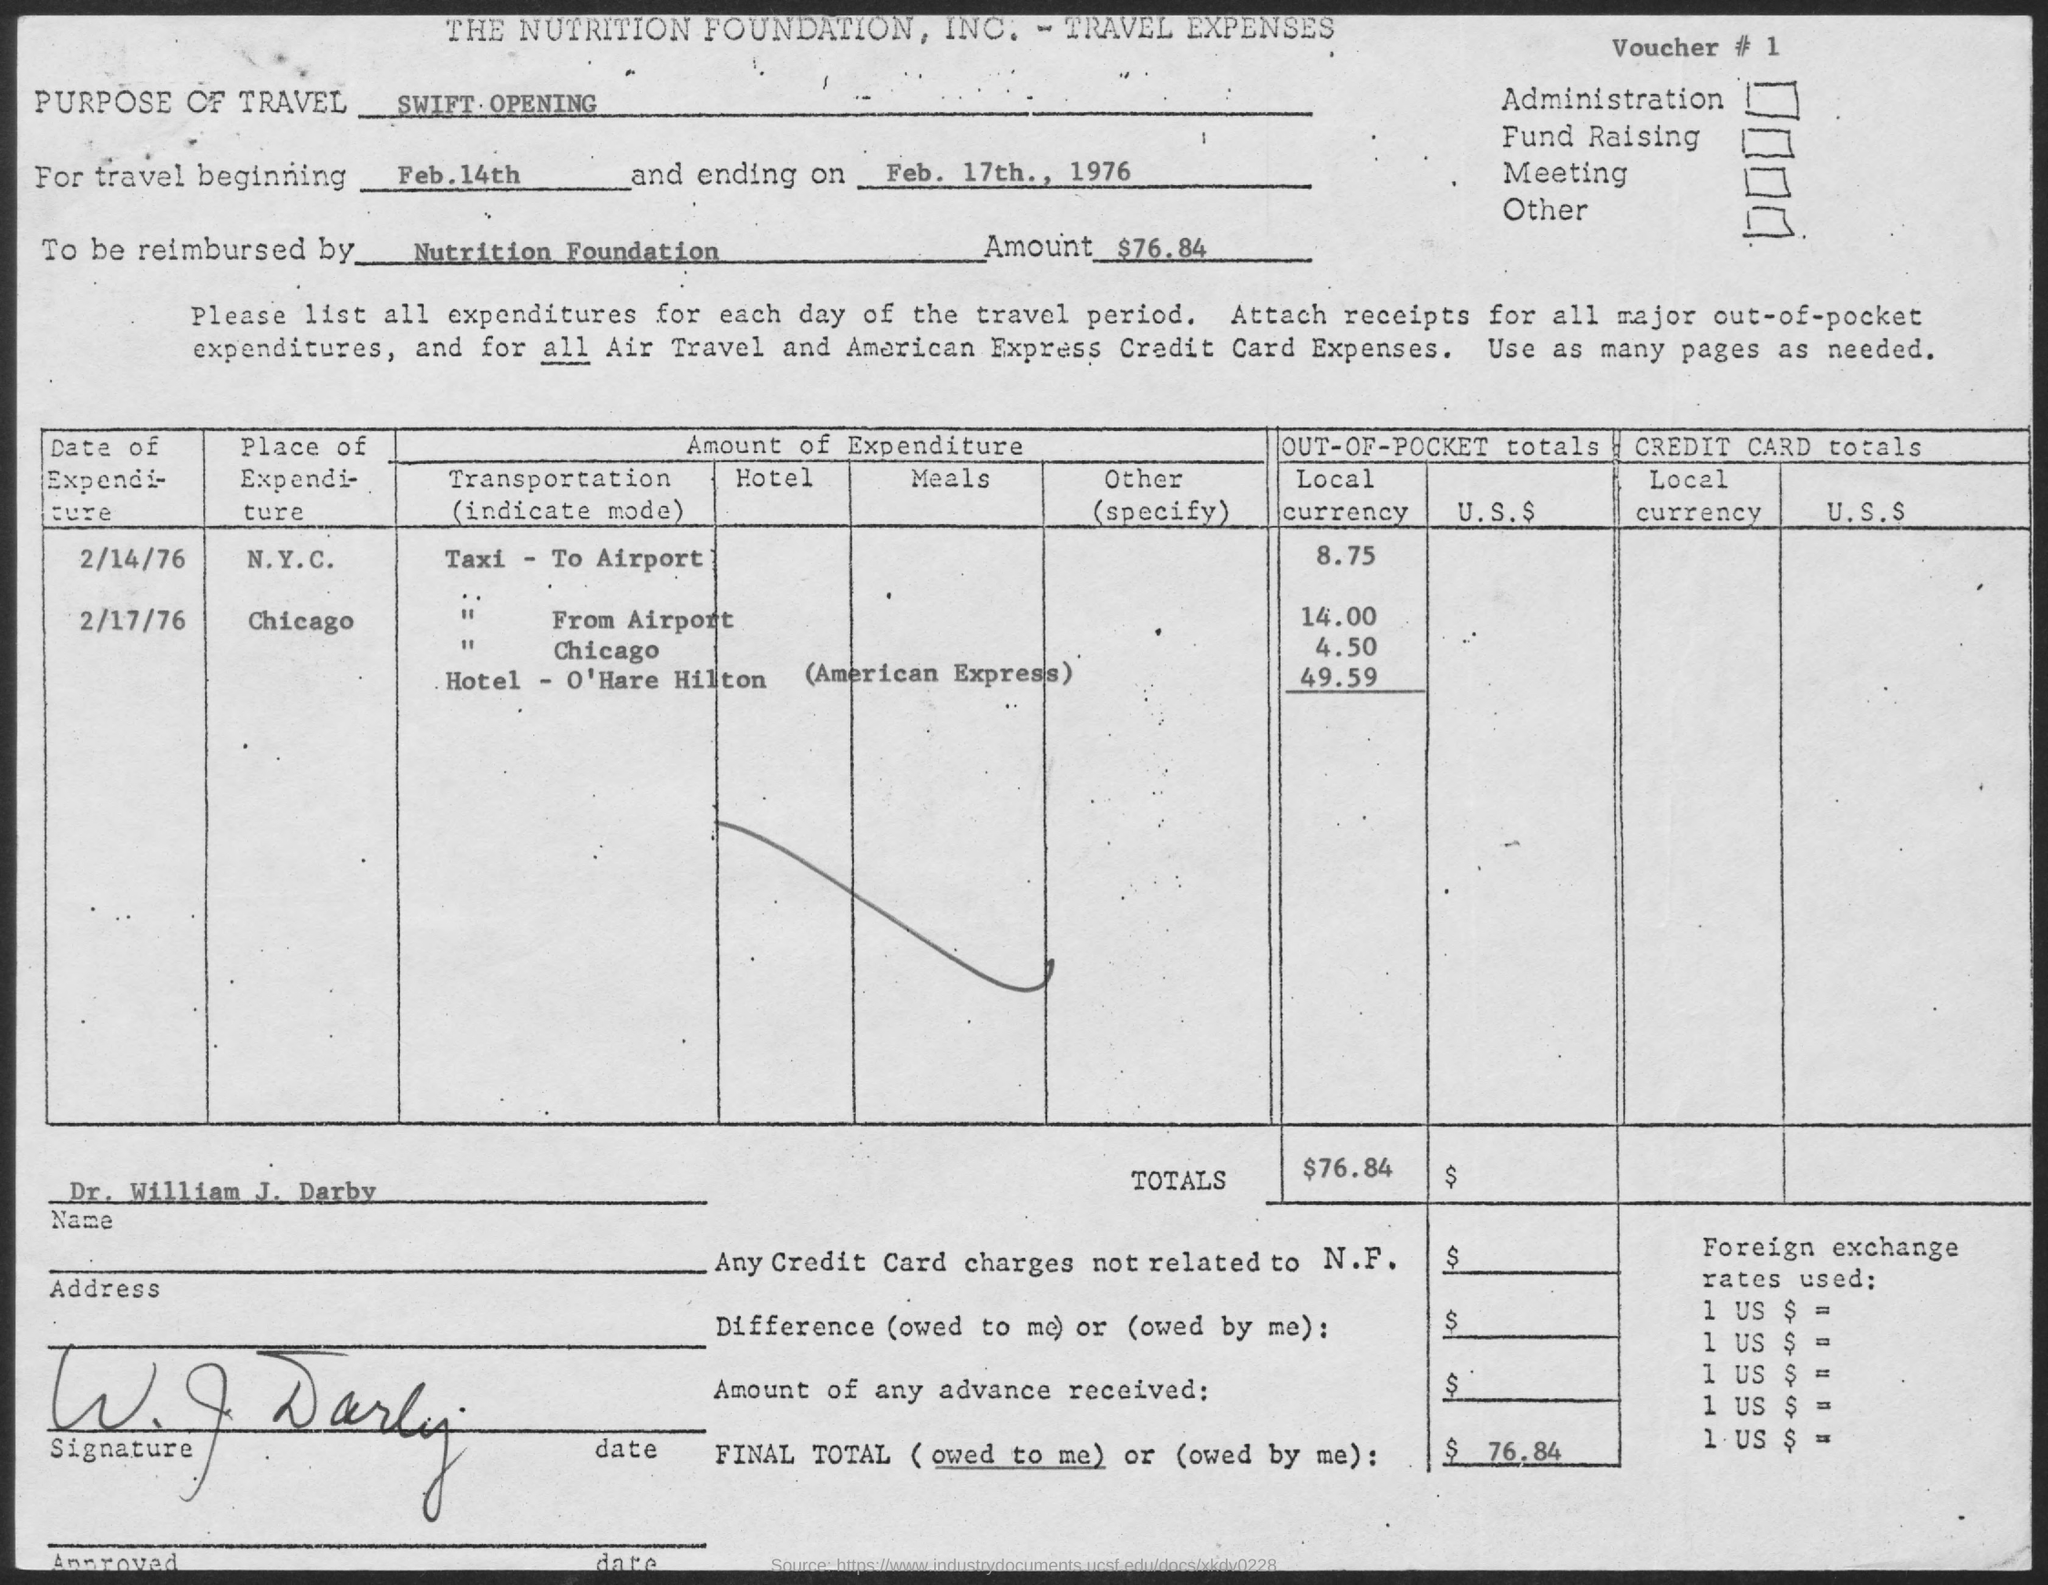What is the Voucher # ?
Provide a succinct answer. 1. What is the travel beginning date ?
Provide a succinct answer. Feb.14th. What is the travel ending date ?
Offer a terse response. Feb. 17th., 1976. 